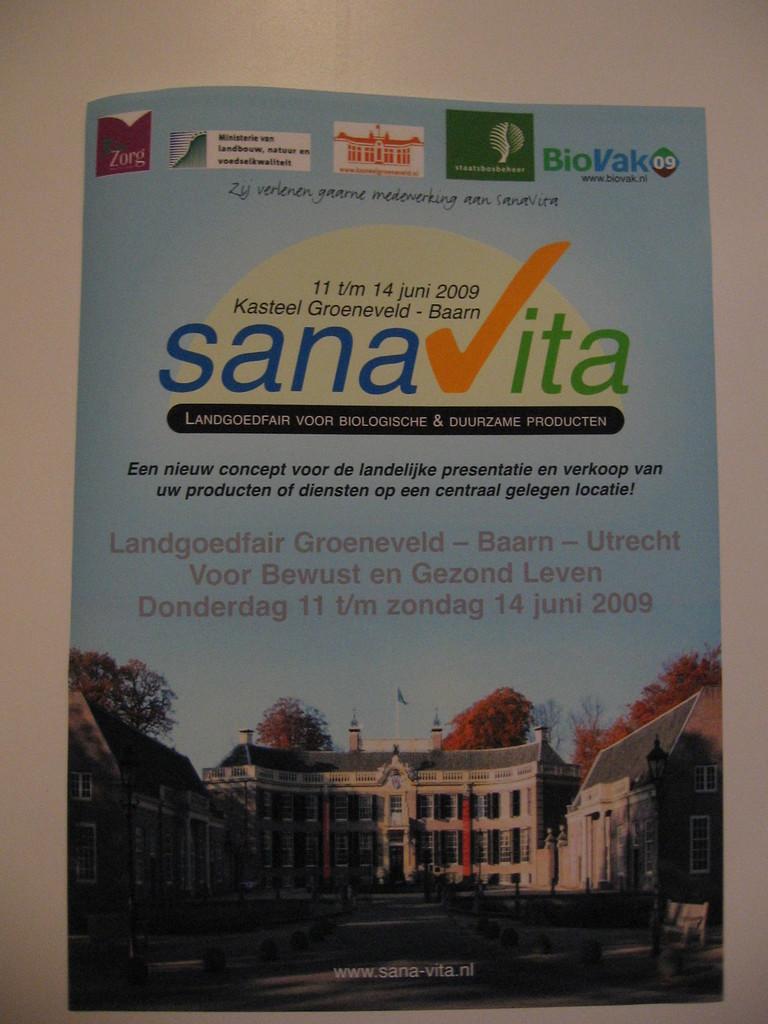What website is advertised on the bottom of the magazine?
Give a very brief answer. Www.sana-vita.nl. 